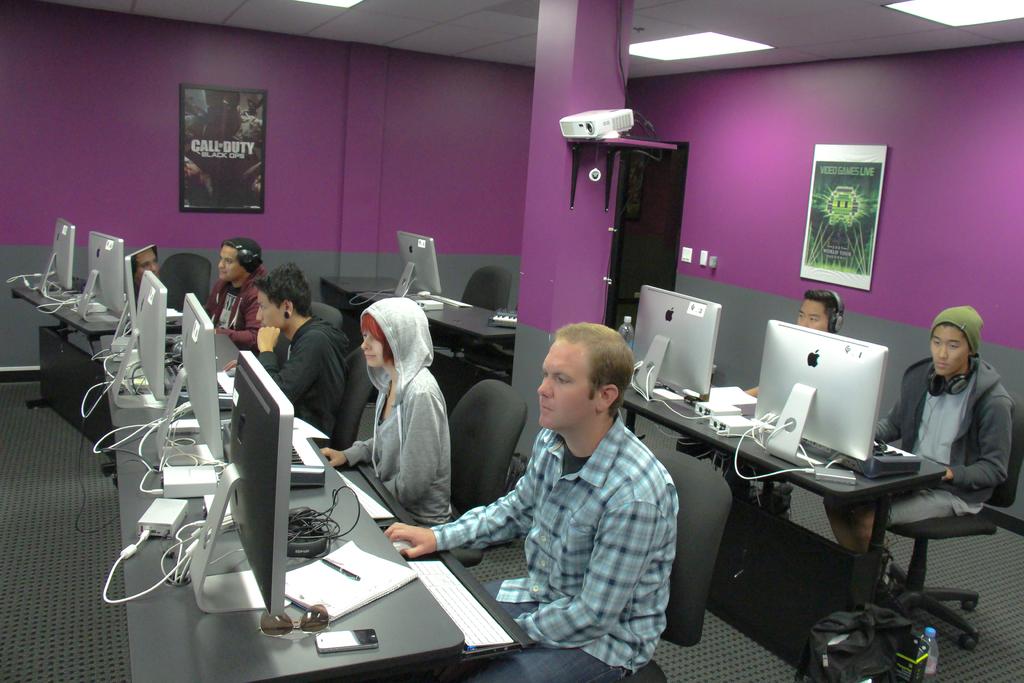What video game is shown on the poster?
Make the answer very short. Call of duty black ops. What s the first letter of the title of the poster on the left?
Ensure brevity in your answer.  C. 